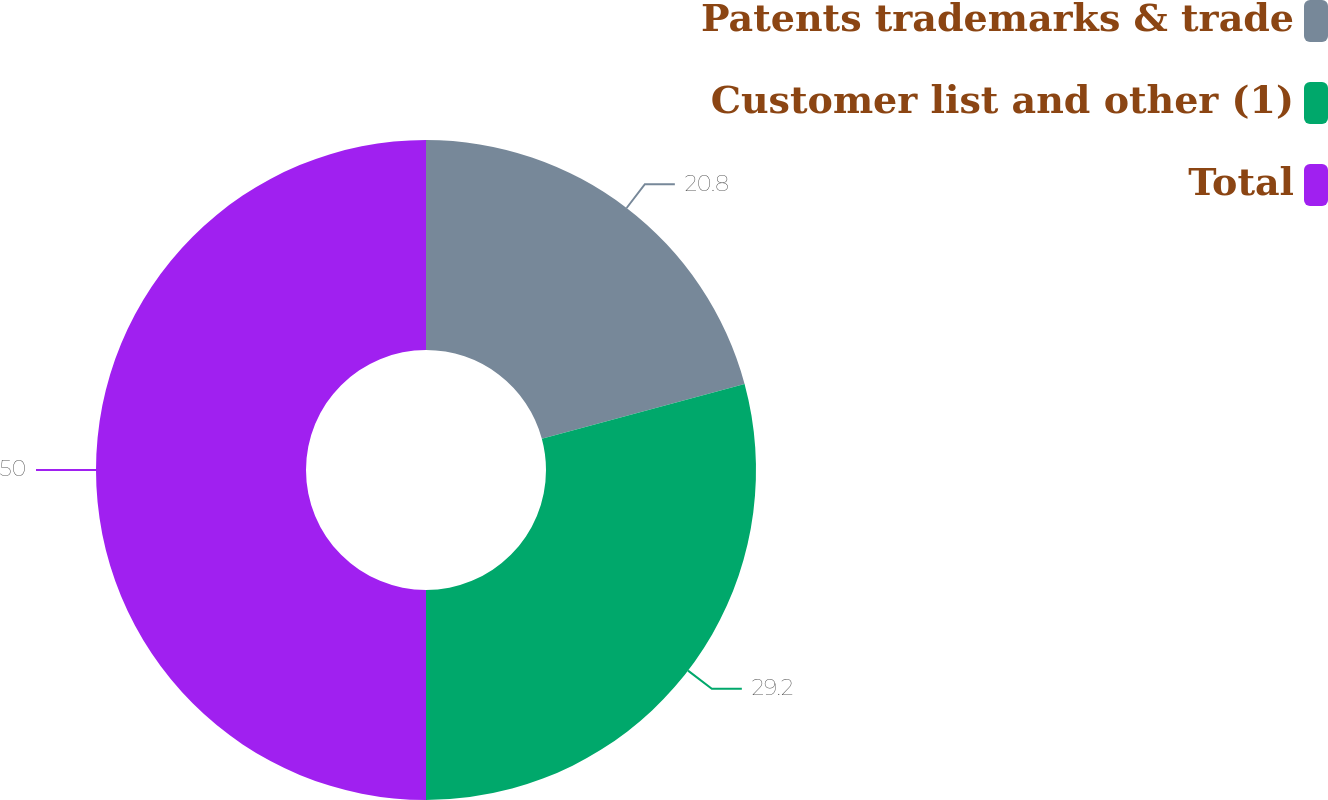Convert chart to OTSL. <chart><loc_0><loc_0><loc_500><loc_500><pie_chart><fcel>Patents trademarks & trade<fcel>Customer list and other (1)<fcel>Total<nl><fcel>20.8%<fcel>29.2%<fcel>50.0%<nl></chart> 